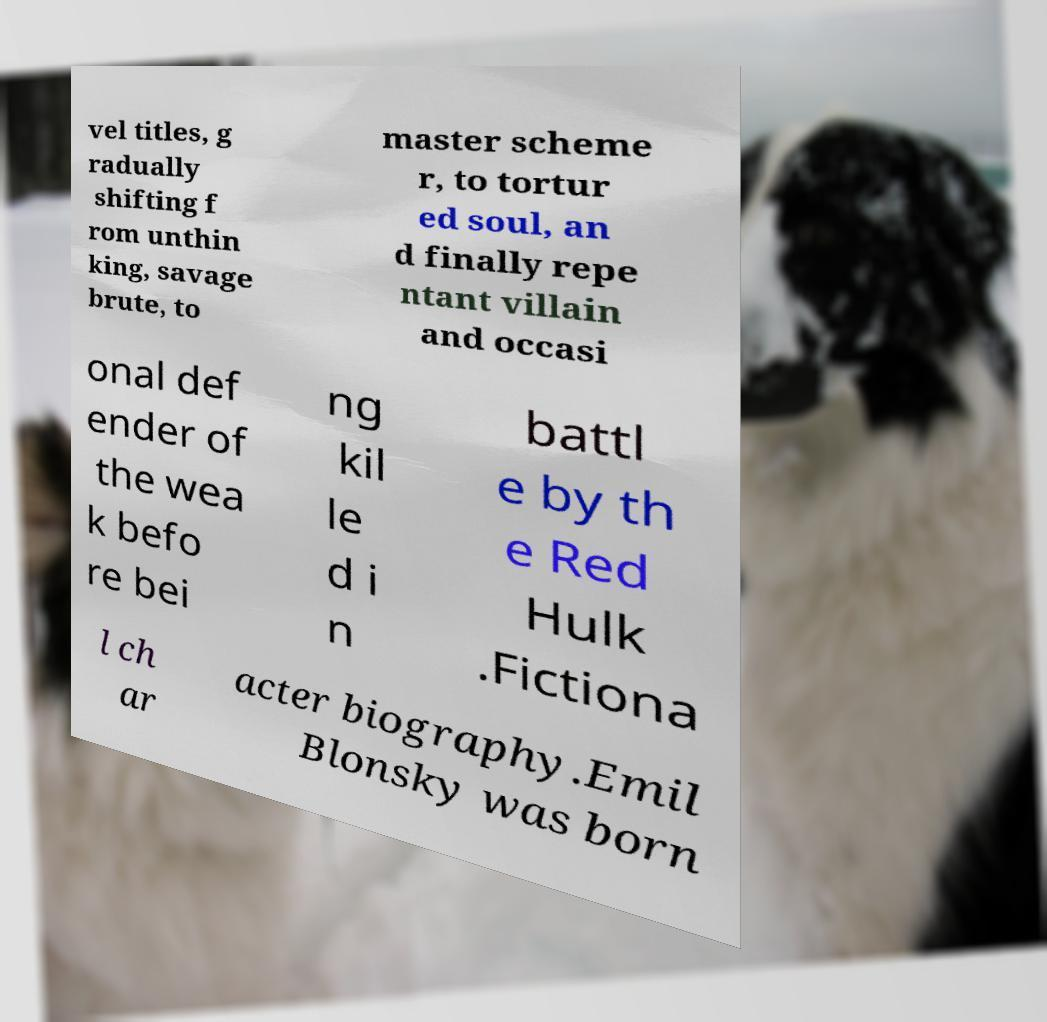Can you accurately transcribe the text from the provided image for me? vel titles, g radually shifting f rom unthin king, savage brute, to master scheme r, to tortur ed soul, an d finally repe ntant villain and occasi onal def ender of the wea k befo re bei ng kil le d i n battl e by th e Red Hulk .Fictiona l ch ar acter biography.Emil Blonsky was born 